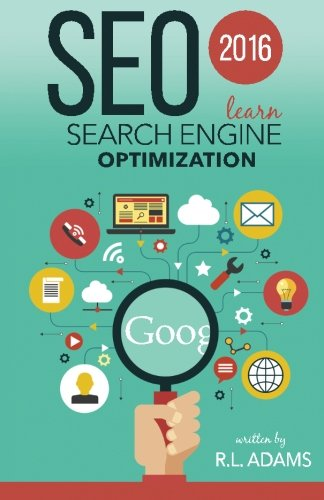What year does this book cover in terms of SEO practices? The book covers SEO practices for the year 2016, providing insights into the most effective strategies and updates in SEO technique during that year. 